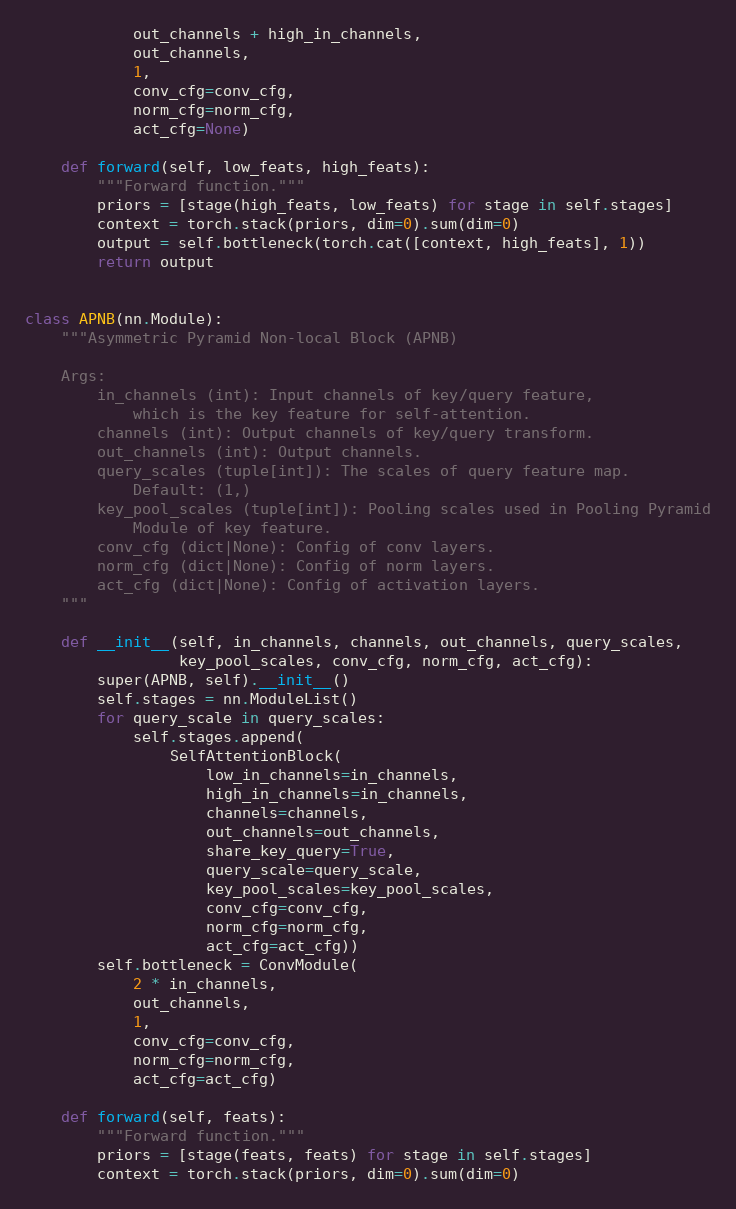Convert code to text. <code><loc_0><loc_0><loc_500><loc_500><_Python_>            out_channels + high_in_channels,
            out_channels,
            1,
            conv_cfg=conv_cfg,
            norm_cfg=norm_cfg,
            act_cfg=None)

    def forward(self, low_feats, high_feats):
        """Forward function."""
        priors = [stage(high_feats, low_feats) for stage in self.stages]
        context = torch.stack(priors, dim=0).sum(dim=0)
        output = self.bottleneck(torch.cat([context, high_feats], 1))
        return output


class APNB(nn.Module):
    """Asymmetric Pyramid Non-local Block (APNB)

    Args:
        in_channels (int): Input channels of key/query feature,
            which is the key feature for self-attention.
        channels (int): Output channels of key/query transform.
        out_channels (int): Output channels.
        query_scales (tuple[int]): The scales of query feature map.
            Default: (1,)
        key_pool_scales (tuple[int]): Pooling scales used in Pooling Pyramid
            Module of key feature.
        conv_cfg (dict|None): Config of conv layers.
        norm_cfg (dict|None): Config of norm layers.
        act_cfg (dict|None): Config of activation layers.
    """

    def __init__(self, in_channels, channels, out_channels, query_scales,
                 key_pool_scales, conv_cfg, norm_cfg, act_cfg):
        super(APNB, self).__init__()
        self.stages = nn.ModuleList()
        for query_scale in query_scales:
            self.stages.append(
                SelfAttentionBlock(
                    low_in_channels=in_channels,
                    high_in_channels=in_channels,
                    channels=channels,
                    out_channels=out_channels,
                    share_key_query=True,
                    query_scale=query_scale,
                    key_pool_scales=key_pool_scales,
                    conv_cfg=conv_cfg,
                    norm_cfg=norm_cfg,
                    act_cfg=act_cfg))
        self.bottleneck = ConvModule(
            2 * in_channels,
            out_channels,
            1,
            conv_cfg=conv_cfg,
            norm_cfg=norm_cfg,
            act_cfg=act_cfg)

    def forward(self, feats):
        """Forward function."""
        priors = [stage(feats, feats) for stage in self.stages]
        context = torch.stack(priors, dim=0).sum(dim=0)</code> 